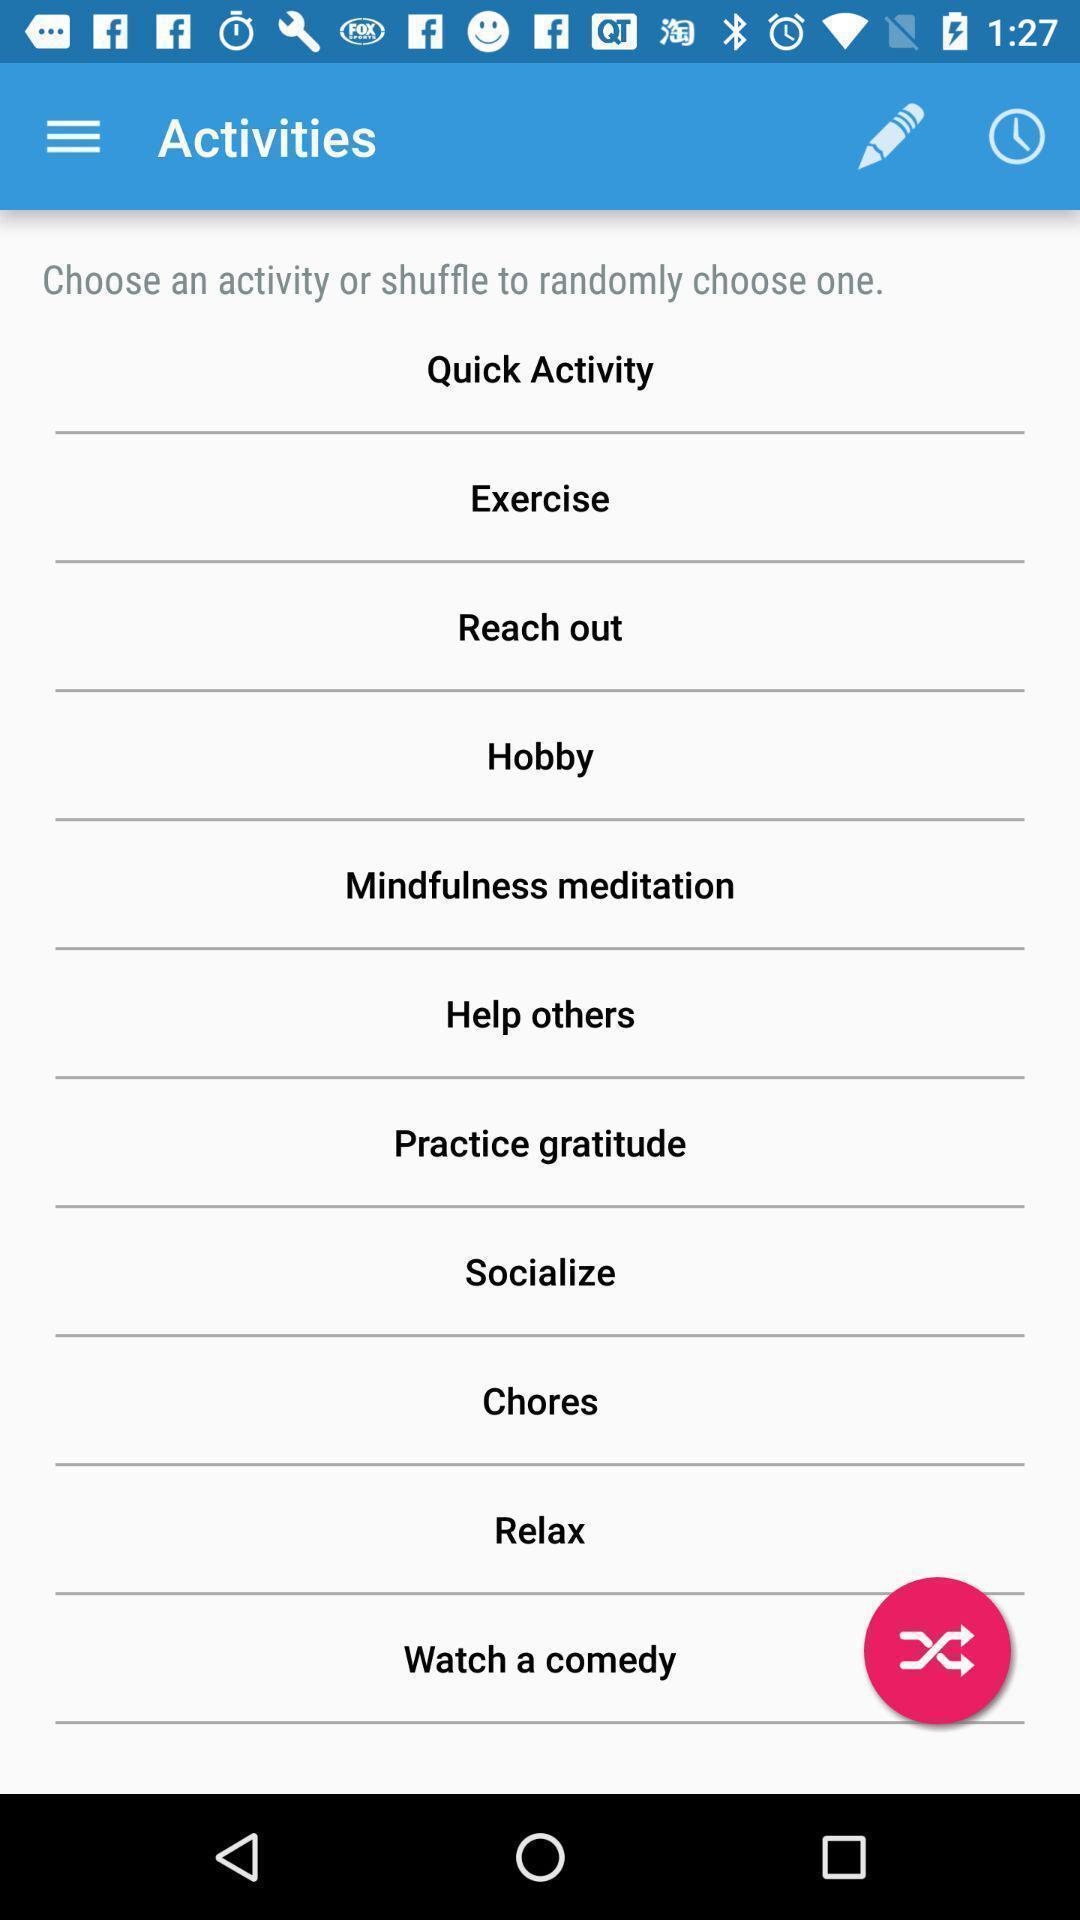What details can you identify in this image? Page showing multiple activities. 